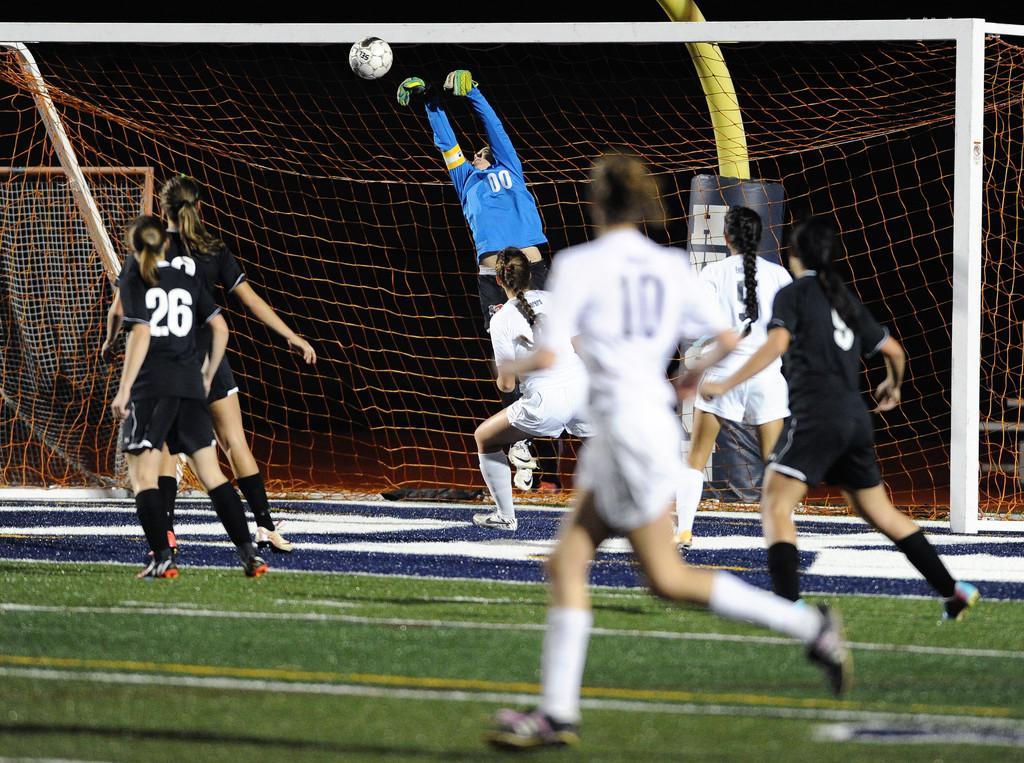Describe this image in one or two sentences. The image is taken during a football game. In this picture there is a football ground, on the ground there are players playing football. In the background there is a goal post and football. The background is dark. 